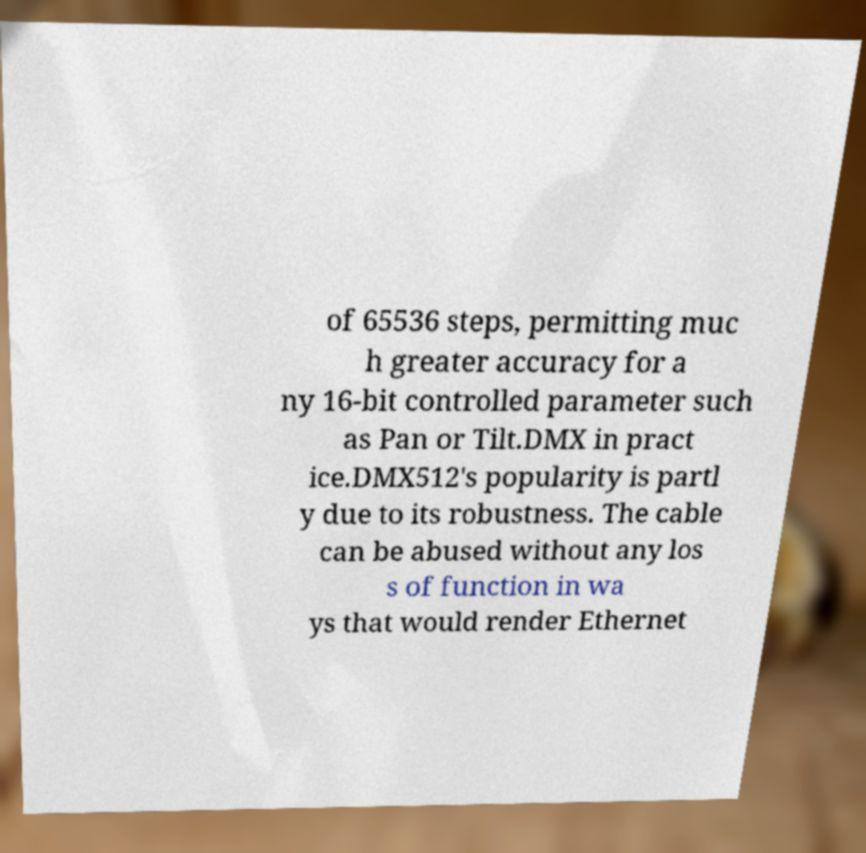Could you extract and type out the text from this image? of 65536 steps, permitting muc h greater accuracy for a ny 16-bit controlled parameter such as Pan or Tilt.DMX in pract ice.DMX512's popularity is partl y due to its robustness. The cable can be abused without any los s of function in wa ys that would render Ethernet 